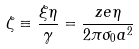<formula> <loc_0><loc_0><loc_500><loc_500>\zeta \equiv \frac { \xi \eta } { \gamma } = \frac { z e \eta } { 2 \pi \sigma _ { 0 } a ^ { 2 } }</formula> 